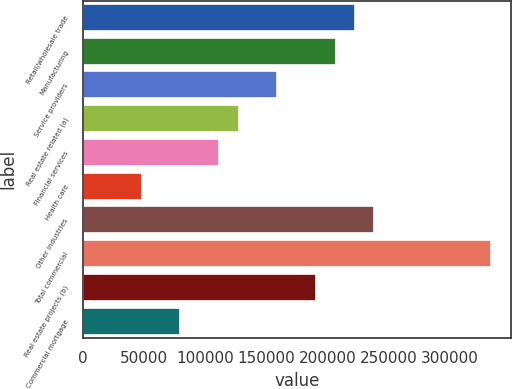Convert chart to OTSL. <chart><loc_0><loc_0><loc_500><loc_500><bar_chart><fcel>Retail/wholesale trade<fcel>Manufacturing<fcel>Service providers<fcel>Real estate related (a)<fcel>Financial services<fcel>Health care<fcel>Other industries<fcel>Total commercial<fcel>Real estate projects (b)<fcel>Commercial mortgage<nl><fcel>222386<fcel>206543<fcel>159014<fcel>127328<fcel>111485<fcel>48113<fcel>238229<fcel>333287<fcel>190700<fcel>79799<nl></chart> 